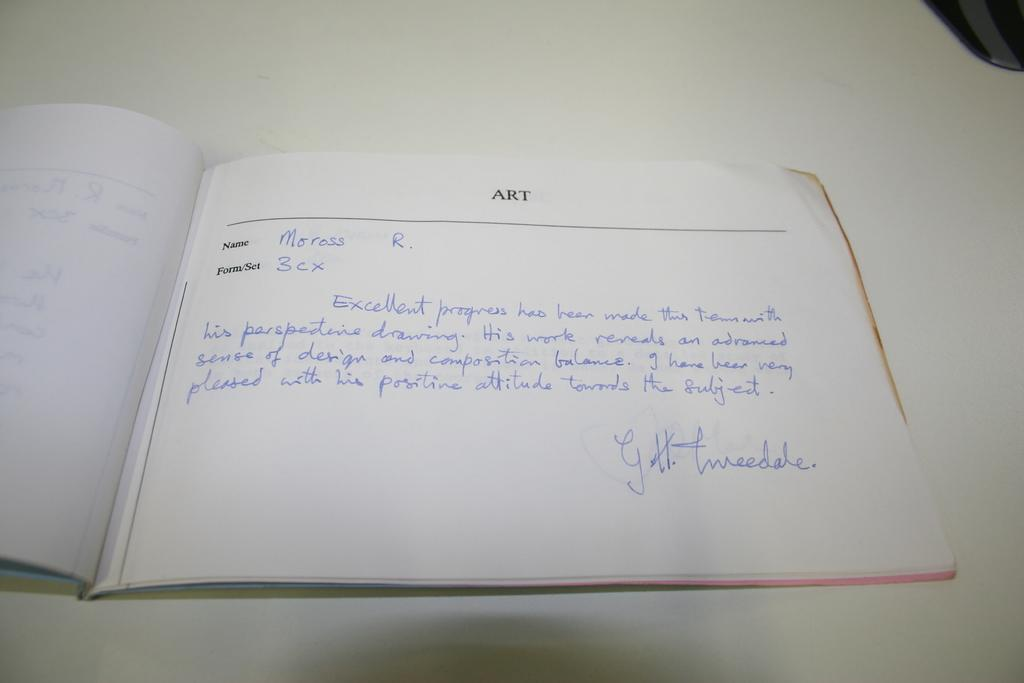<image>
Create a compact narrative representing the image presented. the word art is on a white piece of paper 